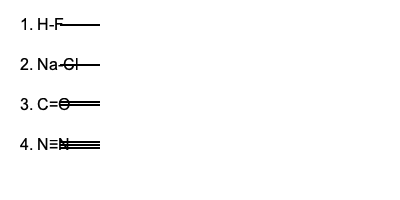Identify the types of chemical bonds represented in each of the molecular structure diagrams above. List them in order from 1 to 4. To identify the types of chemical bonds, we need to consider the elements involved and the number of lines representing the bond:

1. H-F: This is a bond between hydrogen and fluorine. Given the high electronegativity difference between these elements, this is a polar covalent bond.

2. Na-Cl: This represents a bond between sodium (a metal) and chlorine (a non-metal). The large difference in electronegativity results in an ionic bond.

3. C=O: The double line represents a double bond between carbon and oxygen. This is a covalent bond, specifically a polar covalent double bond.

4. N≡N: The triple line represents a triple bond between two nitrogen atoms. As it's between two identical atoms, this is a non-polar covalent triple bond.

Therefore, the types of bonds in order are:
1. Polar covalent
2. Ionic
3. Polar covalent (double bond)
4. Non-polar covalent (triple bond)
Answer: Polar covalent, Ionic, Polar covalent (double), Non-polar covalent (triple) 